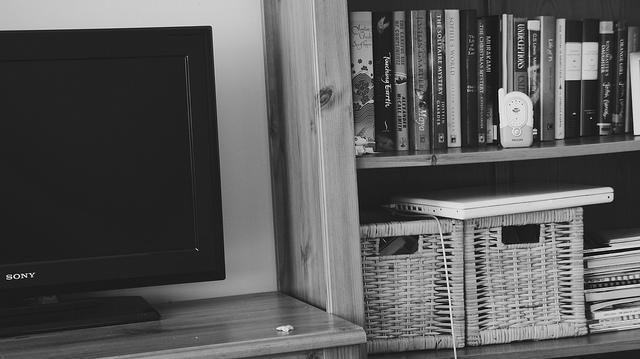How many books are there?
Give a very brief answer. 7. How many of the bears legs are bent?
Give a very brief answer. 0. 